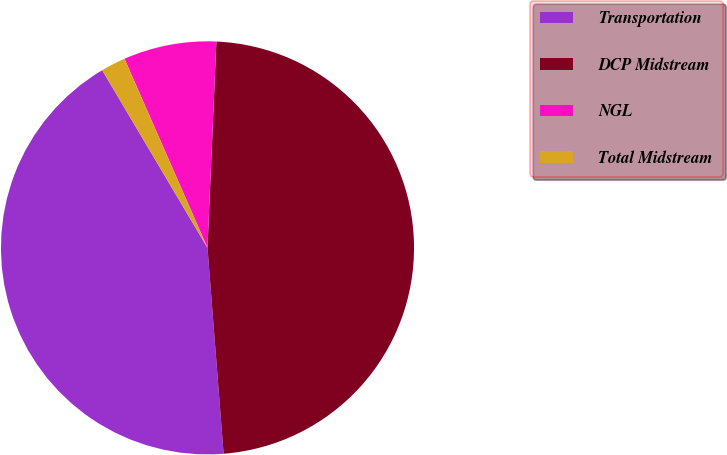Convert chart. <chart><loc_0><loc_0><loc_500><loc_500><pie_chart><fcel>Transportation<fcel>DCP Midstream<fcel>NGL<fcel>Total Midstream<nl><fcel>42.73%<fcel>48.07%<fcel>7.27%<fcel>1.93%<nl></chart> 